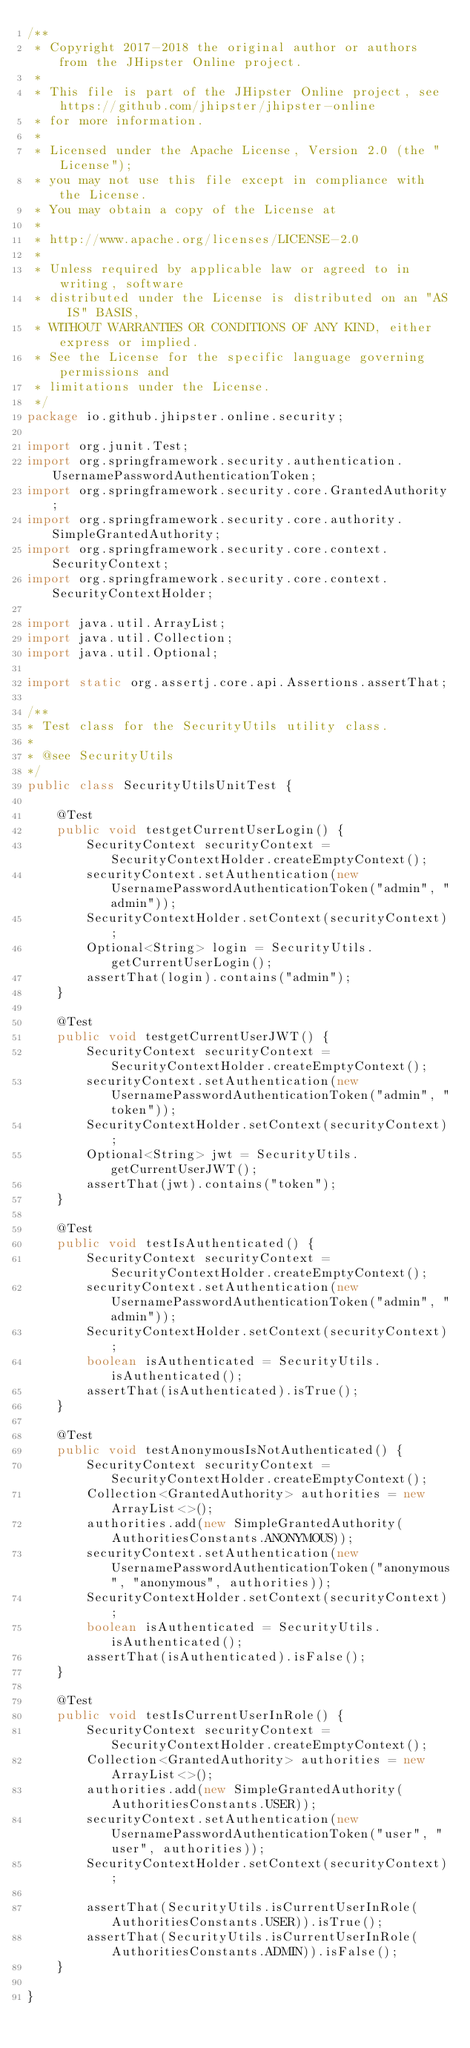Convert code to text. <code><loc_0><loc_0><loc_500><loc_500><_Java_>/**
 * Copyright 2017-2018 the original author or authors from the JHipster Online project.
 *
 * This file is part of the JHipster Online project, see https://github.com/jhipster/jhipster-online
 * for more information.
 *
 * Licensed under the Apache License, Version 2.0 (the "License");
 * you may not use this file except in compliance with the License.
 * You may obtain a copy of the License at
 *
 * http://www.apache.org/licenses/LICENSE-2.0
 *
 * Unless required by applicable law or agreed to in writing, software
 * distributed under the License is distributed on an "AS IS" BASIS,
 * WITHOUT WARRANTIES OR CONDITIONS OF ANY KIND, either express or implied.
 * See the License for the specific language governing permissions and
 * limitations under the License.
 */
package io.github.jhipster.online.security;

import org.junit.Test;
import org.springframework.security.authentication.UsernamePasswordAuthenticationToken;
import org.springframework.security.core.GrantedAuthority;
import org.springframework.security.core.authority.SimpleGrantedAuthority;
import org.springframework.security.core.context.SecurityContext;
import org.springframework.security.core.context.SecurityContextHolder;

import java.util.ArrayList;
import java.util.Collection;
import java.util.Optional;

import static org.assertj.core.api.Assertions.assertThat;

/**
* Test class for the SecurityUtils utility class.
*
* @see SecurityUtils
*/
public class SecurityUtilsUnitTest {

    @Test
    public void testgetCurrentUserLogin() {
        SecurityContext securityContext = SecurityContextHolder.createEmptyContext();
        securityContext.setAuthentication(new UsernamePasswordAuthenticationToken("admin", "admin"));
        SecurityContextHolder.setContext(securityContext);
        Optional<String> login = SecurityUtils.getCurrentUserLogin();
        assertThat(login).contains("admin");
    }

    @Test
    public void testgetCurrentUserJWT() {
        SecurityContext securityContext = SecurityContextHolder.createEmptyContext();
        securityContext.setAuthentication(new UsernamePasswordAuthenticationToken("admin", "token"));
        SecurityContextHolder.setContext(securityContext);
        Optional<String> jwt = SecurityUtils.getCurrentUserJWT();
        assertThat(jwt).contains("token");
    }

    @Test
    public void testIsAuthenticated() {
        SecurityContext securityContext = SecurityContextHolder.createEmptyContext();
        securityContext.setAuthentication(new UsernamePasswordAuthenticationToken("admin", "admin"));
        SecurityContextHolder.setContext(securityContext);
        boolean isAuthenticated = SecurityUtils.isAuthenticated();
        assertThat(isAuthenticated).isTrue();
    }

    @Test
    public void testAnonymousIsNotAuthenticated() {
        SecurityContext securityContext = SecurityContextHolder.createEmptyContext();
        Collection<GrantedAuthority> authorities = new ArrayList<>();
        authorities.add(new SimpleGrantedAuthority(AuthoritiesConstants.ANONYMOUS));
        securityContext.setAuthentication(new UsernamePasswordAuthenticationToken("anonymous", "anonymous", authorities));
        SecurityContextHolder.setContext(securityContext);
        boolean isAuthenticated = SecurityUtils.isAuthenticated();
        assertThat(isAuthenticated).isFalse();
    }

    @Test
    public void testIsCurrentUserInRole() {
        SecurityContext securityContext = SecurityContextHolder.createEmptyContext();
        Collection<GrantedAuthority> authorities = new ArrayList<>();
        authorities.add(new SimpleGrantedAuthority(AuthoritiesConstants.USER));
        securityContext.setAuthentication(new UsernamePasswordAuthenticationToken("user", "user", authorities));
        SecurityContextHolder.setContext(securityContext);

        assertThat(SecurityUtils.isCurrentUserInRole(AuthoritiesConstants.USER)).isTrue();
        assertThat(SecurityUtils.isCurrentUserInRole(AuthoritiesConstants.ADMIN)).isFalse();
    }

}
</code> 